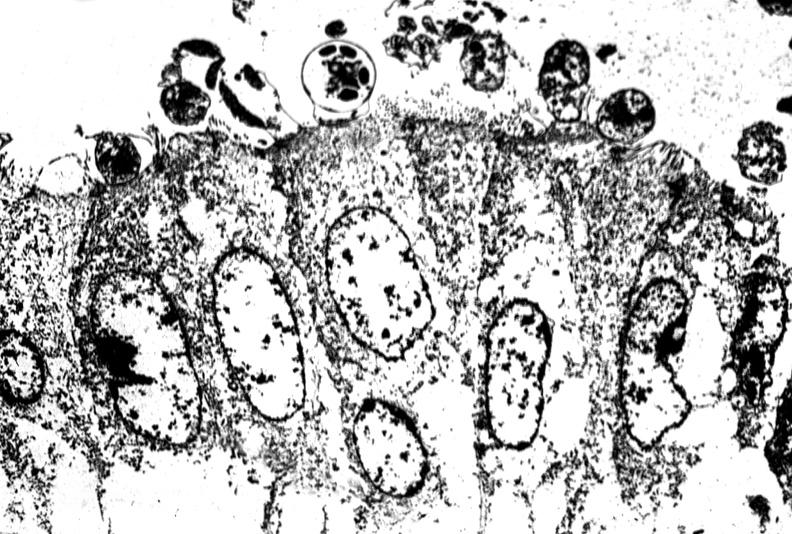s gastrointestinal present?
Answer the question using a single word or phrase. Yes 